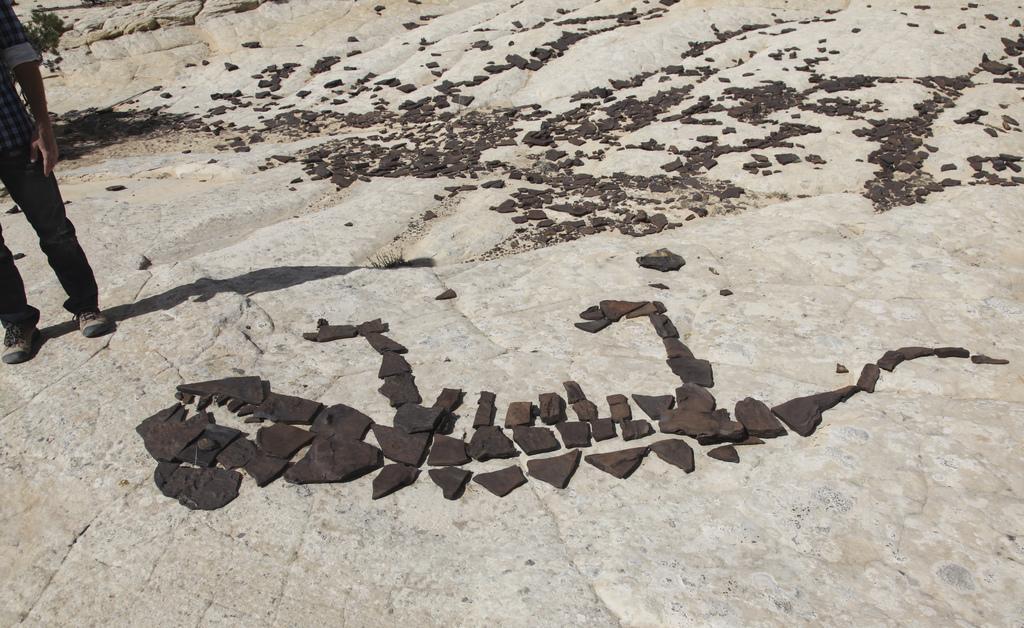Describe this image in one or two sentences. In this image, on the left side, we can see a person standing on the land. In the middle of the image, we can see some rocks. In the background, we can see some stones on the land. 